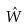Convert formula to latex. <formula><loc_0><loc_0><loc_500><loc_500>\hat { W }</formula> 